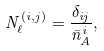Convert formula to latex. <formula><loc_0><loc_0><loc_500><loc_500>N ^ { ( i , j ) } _ { \ell } = \frac { \delta _ { i j } } { \bar { n } _ { A } ^ { i } } ,</formula> 